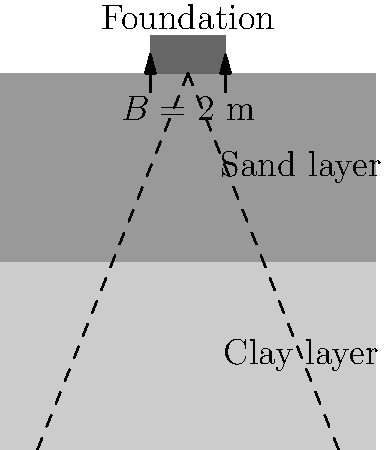As a full-stack developer integrating geotechnical data into your software solution, you need to calculate the settlement of a shallow foundation using the elastic theory. Given a square foundation with width $B = 2$ m, resting on a layered soil profile with a 2 m thick sand layer ($E_s = 50$ MPa, $\nu_s = 0.3$) over a clay layer ($E_c = 20$ MPa, $\nu_c = 0.4$), and a uniform pressure of 200 kPa, what is the total settlement of the foundation? To calculate the settlement of the shallow foundation using elastic theory, we'll follow these steps:

1. Calculate the settlement for each layer separately.
2. Use the equation: $S = q B \frac{1-\nu^2}{E} I_s$, where:
   $S$ = settlement
   $q$ = applied pressure
   $B$ = foundation width
   $\nu$ = Poisson's ratio
   $E$ = Young's modulus
   $I_s$ = influence factor (use 0.95 for square foundation)

3. For the sand layer:
   $S_s = 200 \cdot 2 \cdot \frac{1-0.3^2}{50 \cdot 10^6} \cdot 0.95 = 0.00140$ m

4. For the clay layer:
   $S_c = 200 \cdot 2 \cdot \frac{1-0.4^2}{20 \cdot 10^6} \cdot 0.95 = 0.00285$ m

5. Total settlement:
   $S_{total} = S_s + S_c = 0.00140 + 0.00285 = 0.00425$ m

6. Convert to millimeters:
   $S_{total} = 0.00425 \cdot 1000 = 4.25$ mm
Answer: 4.25 mm 